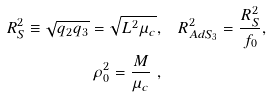<formula> <loc_0><loc_0><loc_500><loc_500>R ^ { 2 } _ { S } \equiv \sqrt { q _ { 2 } q _ { 3 } } = \sqrt { L ^ { 2 } \mu _ { c } } , & \quad R ^ { 2 } _ { A d S _ { 3 } } = \frac { R ^ { 2 } _ { S } } { f _ { 0 } } , \\ \rho _ { 0 } ^ { 2 } = \frac { M } { \mu _ { c } } \ ,</formula> 